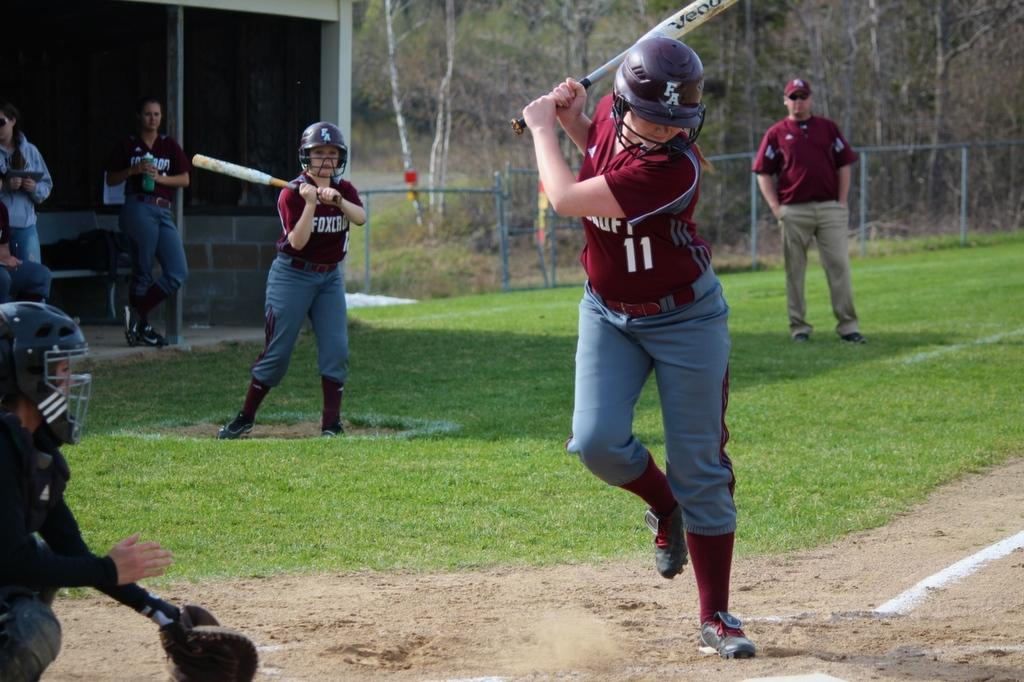<image>
Provide a brief description of the given image. Player 11 with a FA batting helmet on prepares to hit the ball. 